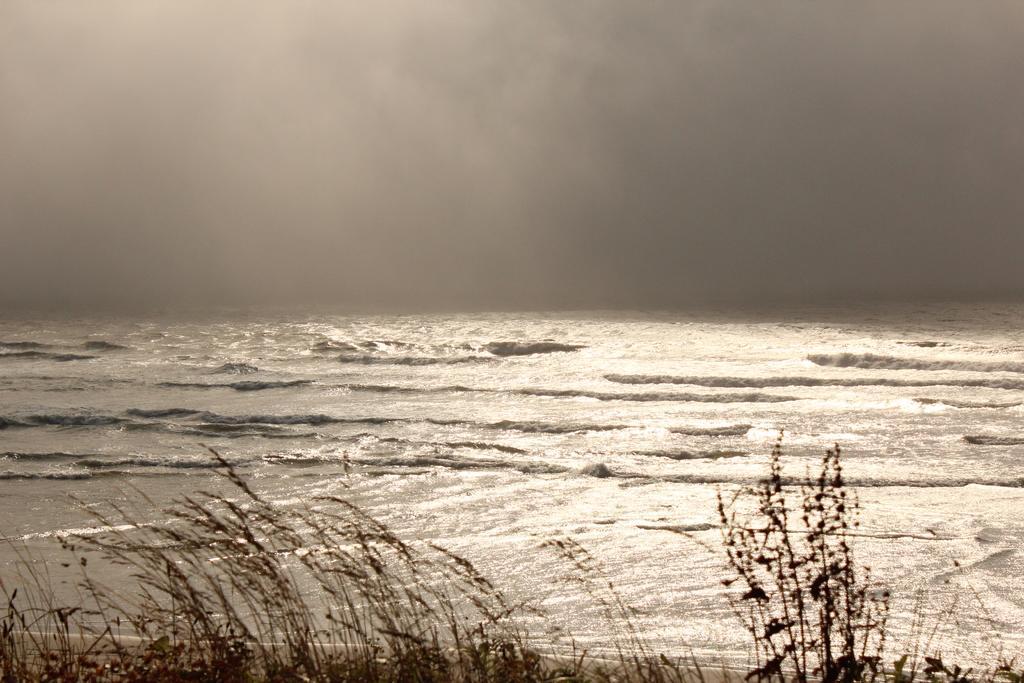In one or two sentences, can you explain what this image depicts? Here we can see grass and we can see water. In the background we can see sky is cloudy. 